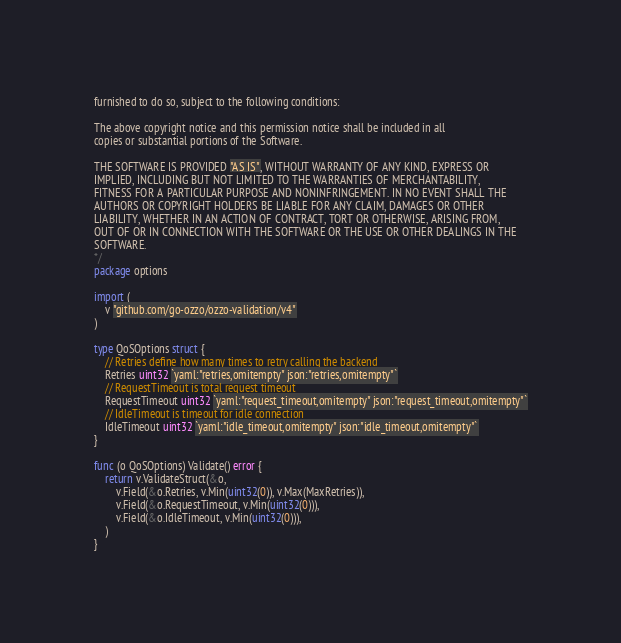Convert code to text. <code><loc_0><loc_0><loc_500><loc_500><_Go_>furnished to do so, subject to the following conditions:

The above copyright notice and this permission notice shall be included in all
copies or substantial portions of the Software.

THE SOFTWARE IS PROVIDED "AS IS", WITHOUT WARRANTY OF ANY KIND, EXPRESS OR
IMPLIED, INCLUDING BUT NOT LIMITED TO THE WARRANTIES OF MERCHANTABILITY,
FITNESS FOR A PARTICULAR PURPOSE AND NONINFRINGEMENT. IN NO EVENT SHALL THE
AUTHORS OR COPYRIGHT HOLDERS BE LIABLE FOR ANY CLAIM, DAMAGES OR OTHER
LIABILITY, WHETHER IN AN ACTION OF CONTRACT, TORT OR OTHERWISE, ARISING FROM,
OUT OF OR IN CONNECTION WITH THE SOFTWARE OR THE USE OR OTHER DEALINGS IN THE
SOFTWARE.
*/
package options

import (
	v "github.com/go-ozzo/ozzo-validation/v4"
)

type QoSOptions struct {
	// Retries define how many times to retry calling the backend
	Retries uint32 `yaml:"retries,omitempty" json:"retries,omitempty"`
	// RequestTimeout is total request timeout
	RequestTimeout uint32 `yaml:"request_timeout,omitempty" json:"request_timeout,omitempty"`
	// IdleTimeout is timeout for idle connection
	IdleTimeout uint32 `yaml:"idle_timeout,omitempty" json:"idle_timeout,omitempty"`
}

func (o QoSOptions) Validate() error {
	return v.ValidateStruct(&o,
		v.Field(&o.Retries, v.Min(uint32(0)), v.Max(MaxRetries)),
		v.Field(&o.RequestTimeout, v.Min(uint32(0))),
		v.Field(&o.IdleTimeout, v.Min(uint32(0))),
	)
}
</code> 